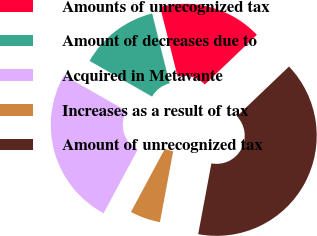<chart> <loc_0><loc_0><loc_500><loc_500><pie_chart><fcel>Amounts of unrecognized tax<fcel>Amount of decreases due to<fcel>Acquired in Metavante<fcel>Increases as a result of tax<fcel>Amount of unrecognized tax<nl><fcel>16.78%<fcel>12.82%<fcel>25.43%<fcel>4.9%<fcel>40.07%<nl></chart> 